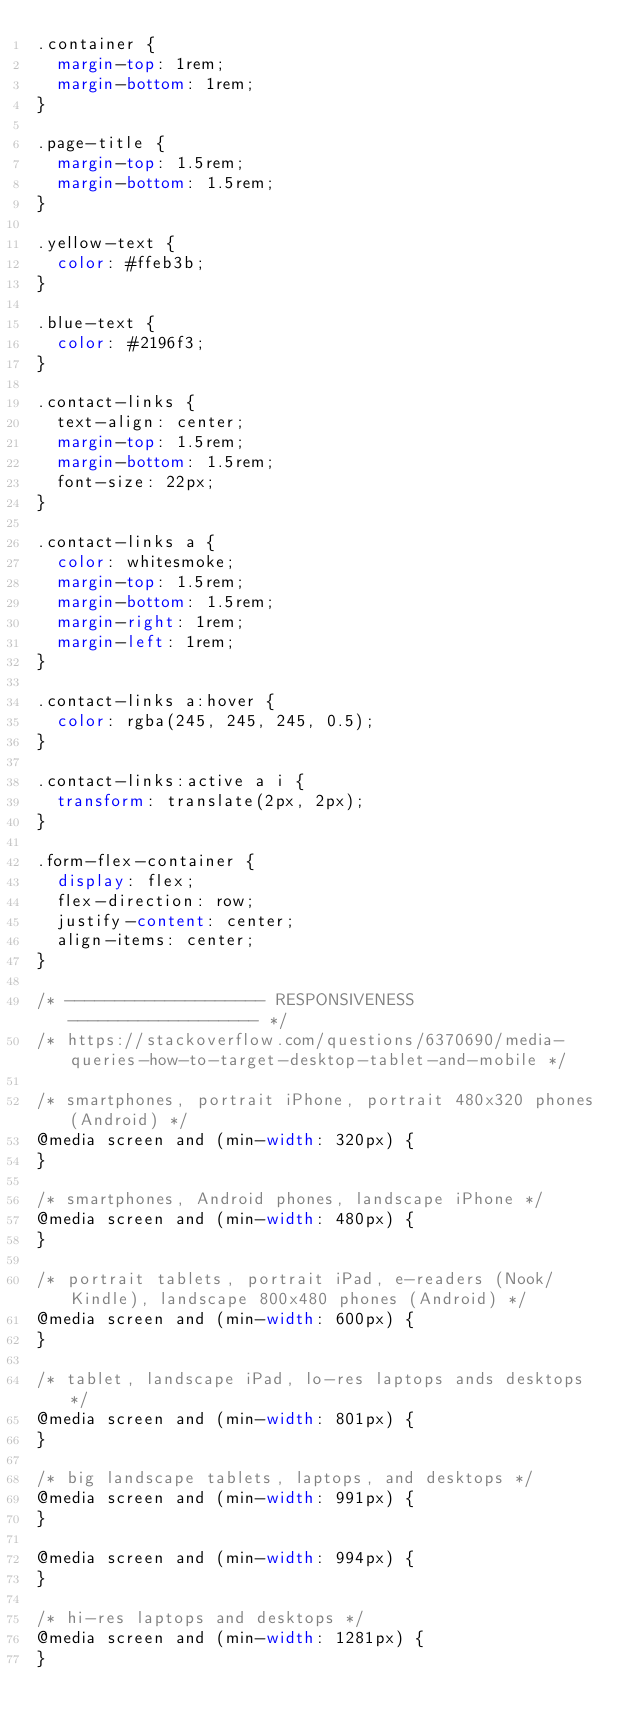Convert code to text. <code><loc_0><loc_0><loc_500><loc_500><_CSS_>.container {
  margin-top: 1rem;
  margin-bottom: 1rem;
}

.page-title {
  margin-top: 1.5rem;
  margin-bottom: 1.5rem;
}

.yellow-text {
  color: #ffeb3b;
}

.blue-text {
  color: #2196f3;
}

.contact-links {
  text-align: center;
  margin-top: 1.5rem;
  margin-bottom: 1.5rem;
  font-size: 22px;
}

.contact-links a {
  color: whitesmoke;
  margin-top: 1.5rem;
  margin-bottom: 1.5rem;
  margin-right: 1rem;
  margin-left: 1rem;
}

.contact-links a:hover {
  color: rgba(245, 245, 245, 0.5);
}

.contact-links:active a i {
  transform: translate(2px, 2px);
}

.form-flex-container {
  display: flex;
  flex-direction: row;
  justify-content: center;
  align-items: center;
}

/* -------------------- RESPONSIVENESS ------------------- */
/* https://stackoverflow.com/questions/6370690/media-queries-how-to-target-desktop-tablet-and-mobile */

/* smartphones, portrait iPhone, portrait 480x320 phones (Android) */
@media screen and (min-width: 320px) {
}

/* smartphones, Android phones, landscape iPhone */
@media screen and (min-width: 480px) {
}

/* portrait tablets, portrait iPad, e-readers (Nook/Kindle), landscape 800x480 phones (Android) */
@media screen and (min-width: 600px) {
}

/* tablet, landscape iPad, lo-res laptops ands desktops */
@media screen and (min-width: 801px) {
}

/* big landscape tablets, laptops, and desktops */
@media screen and (min-width: 991px) {
}

@media screen and (min-width: 994px) {
}

/* hi-res laptops and desktops */
@media screen and (min-width: 1281px) {
}
</code> 